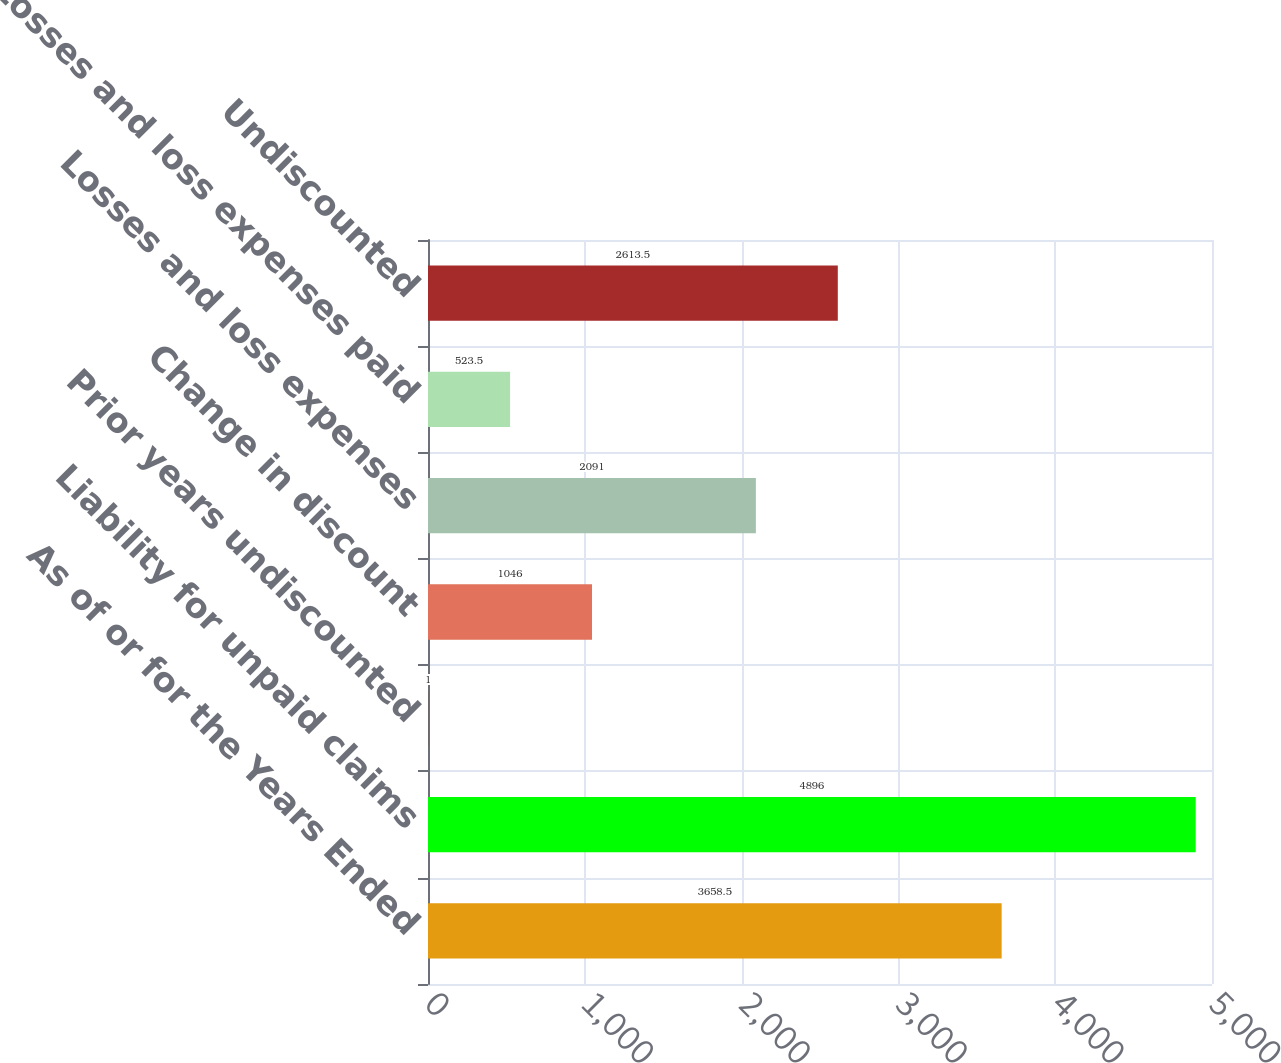Convert chart to OTSL. <chart><loc_0><loc_0><loc_500><loc_500><bar_chart><fcel>As of or for the Years Ended<fcel>Liability for unpaid claims<fcel>Prior years undiscounted<fcel>Change in discount<fcel>Losses and loss expenses<fcel>Losses and loss expenses paid<fcel>Undiscounted<nl><fcel>3658.5<fcel>4896<fcel>1<fcel>1046<fcel>2091<fcel>523.5<fcel>2613.5<nl></chart> 